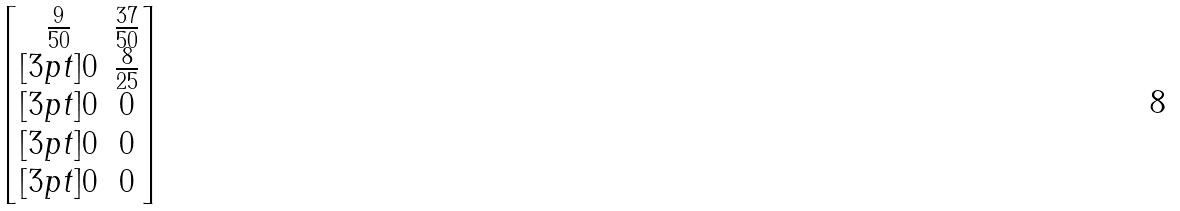Convert formula to latex. <formula><loc_0><loc_0><loc_500><loc_500>\begin{bmatrix} \frac { 9 } { 5 0 } & \frac { 3 7 } { 5 0 } \\ [ 3 p t ] 0 & \frac { 8 } { 2 5 } \\ [ 3 p t ] 0 & 0 \\ [ 3 p t ] 0 & 0 \\ [ 3 p t ] 0 & 0 \end{bmatrix}</formula> 